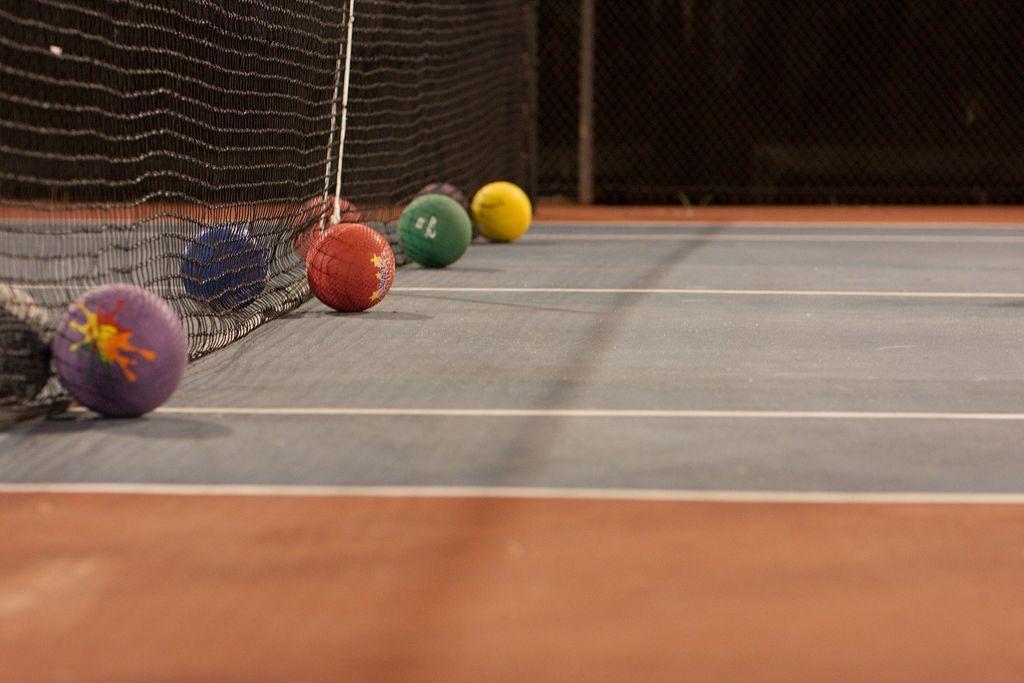Describe this image in one or two sentences. In this picture, we see balls in purple, red, blue, green and yellow color. Beside that, we see a net. At the bottom of the picture, we see a carpet or a floor in grey and brown color. In the background, we see a pole. In the background, it is black in color. This picture might be clicked in the indoor stadium. 